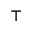<formula> <loc_0><loc_0><loc_500><loc_500>\intercal</formula> 